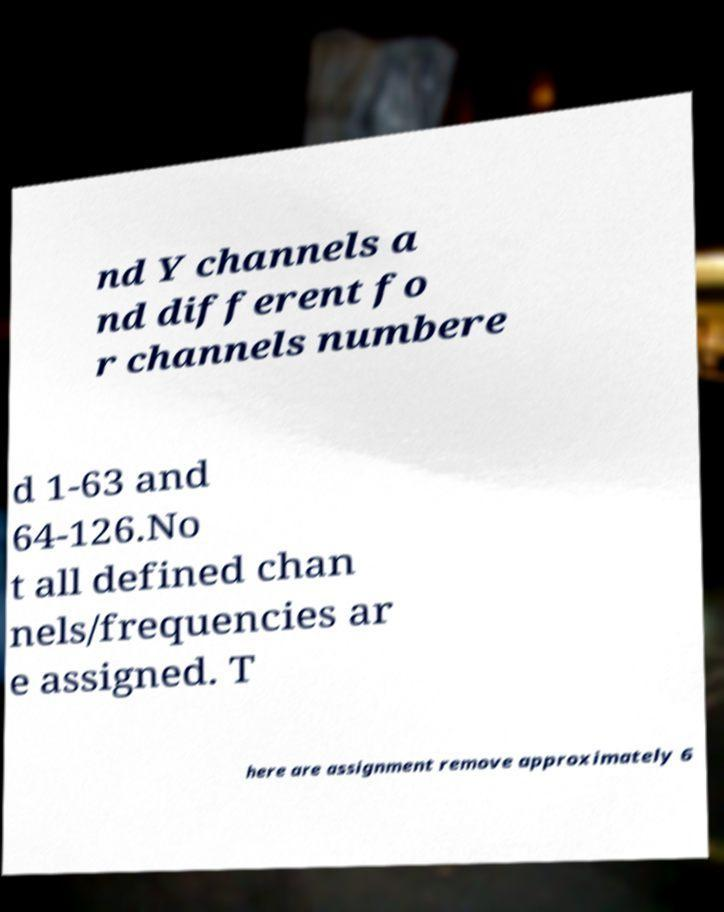Can you read and provide the text displayed in the image?This photo seems to have some interesting text. Can you extract and type it out for me? nd Y channels a nd different fo r channels numbere d 1-63 and 64-126.No t all defined chan nels/frequencies ar e assigned. T here are assignment remove approximately 6 